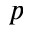Convert formula to latex. <formula><loc_0><loc_0><loc_500><loc_500>p</formula> 